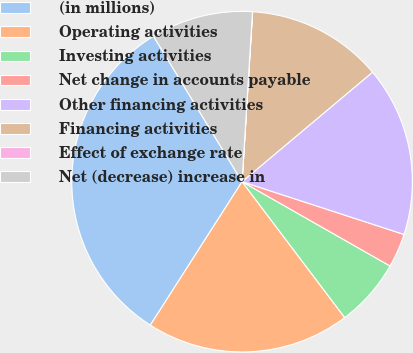<chart> <loc_0><loc_0><loc_500><loc_500><pie_chart><fcel>(in millions)<fcel>Operating activities<fcel>Investing activities<fcel>Net change in accounts payable<fcel>Other financing activities<fcel>Financing activities<fcel>Effect of exchange rate<fcel>Net (decrease) increase in<nl><fcel>32.24%<fcel>19.35%<fcel>6.46%<fcel>3.23%<fcel>16.13%<fcel>12.9%<fcel>0.01%<fcel>9.68%<nl></chart> 